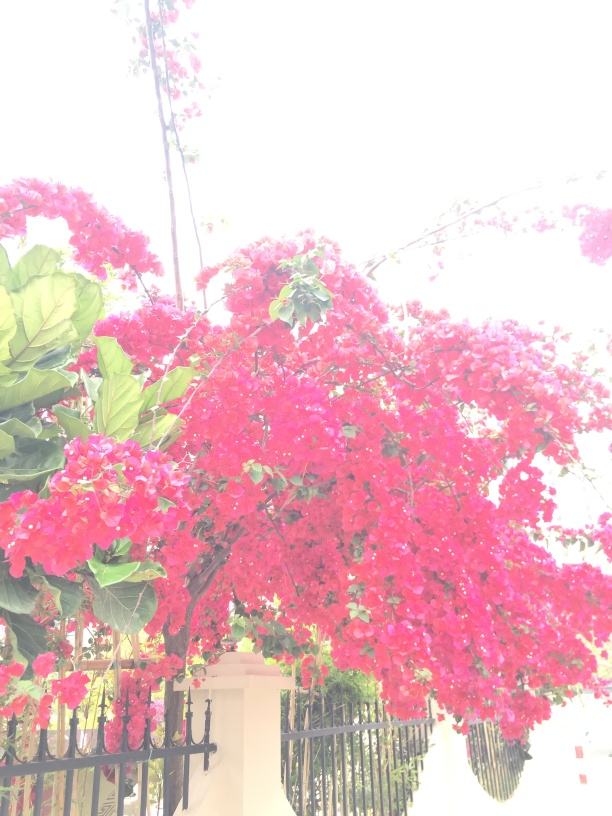Can you tell me more about the flowers shown in the picture? Absolutely, the image prominently features a dense cluster of bright red flowers that appear to be Bougainvillea, a genus of thorny ornamental vines known for their vibrant blossoms. These plants are commonly used in landscaping and garden design due to their striking colors and ability to thrive in warm climates. 